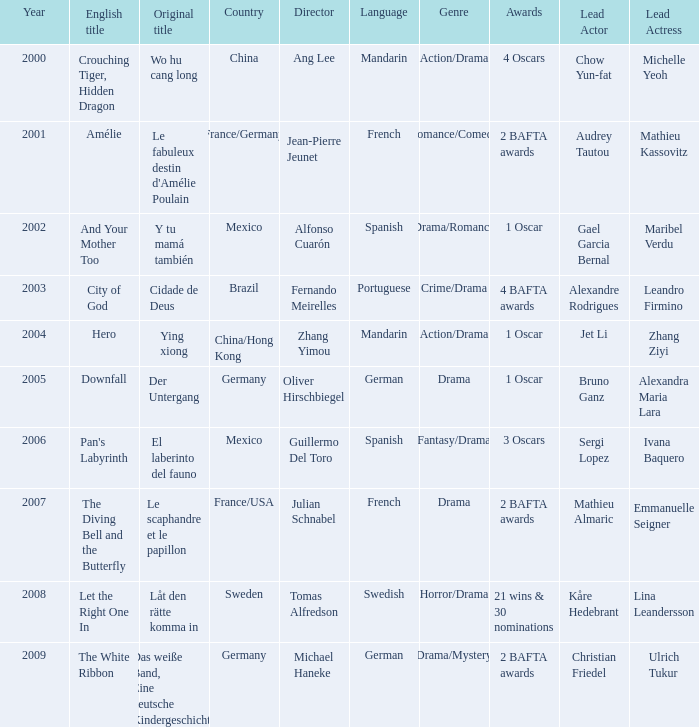Tell me the country for julian schnabel France/USA. 